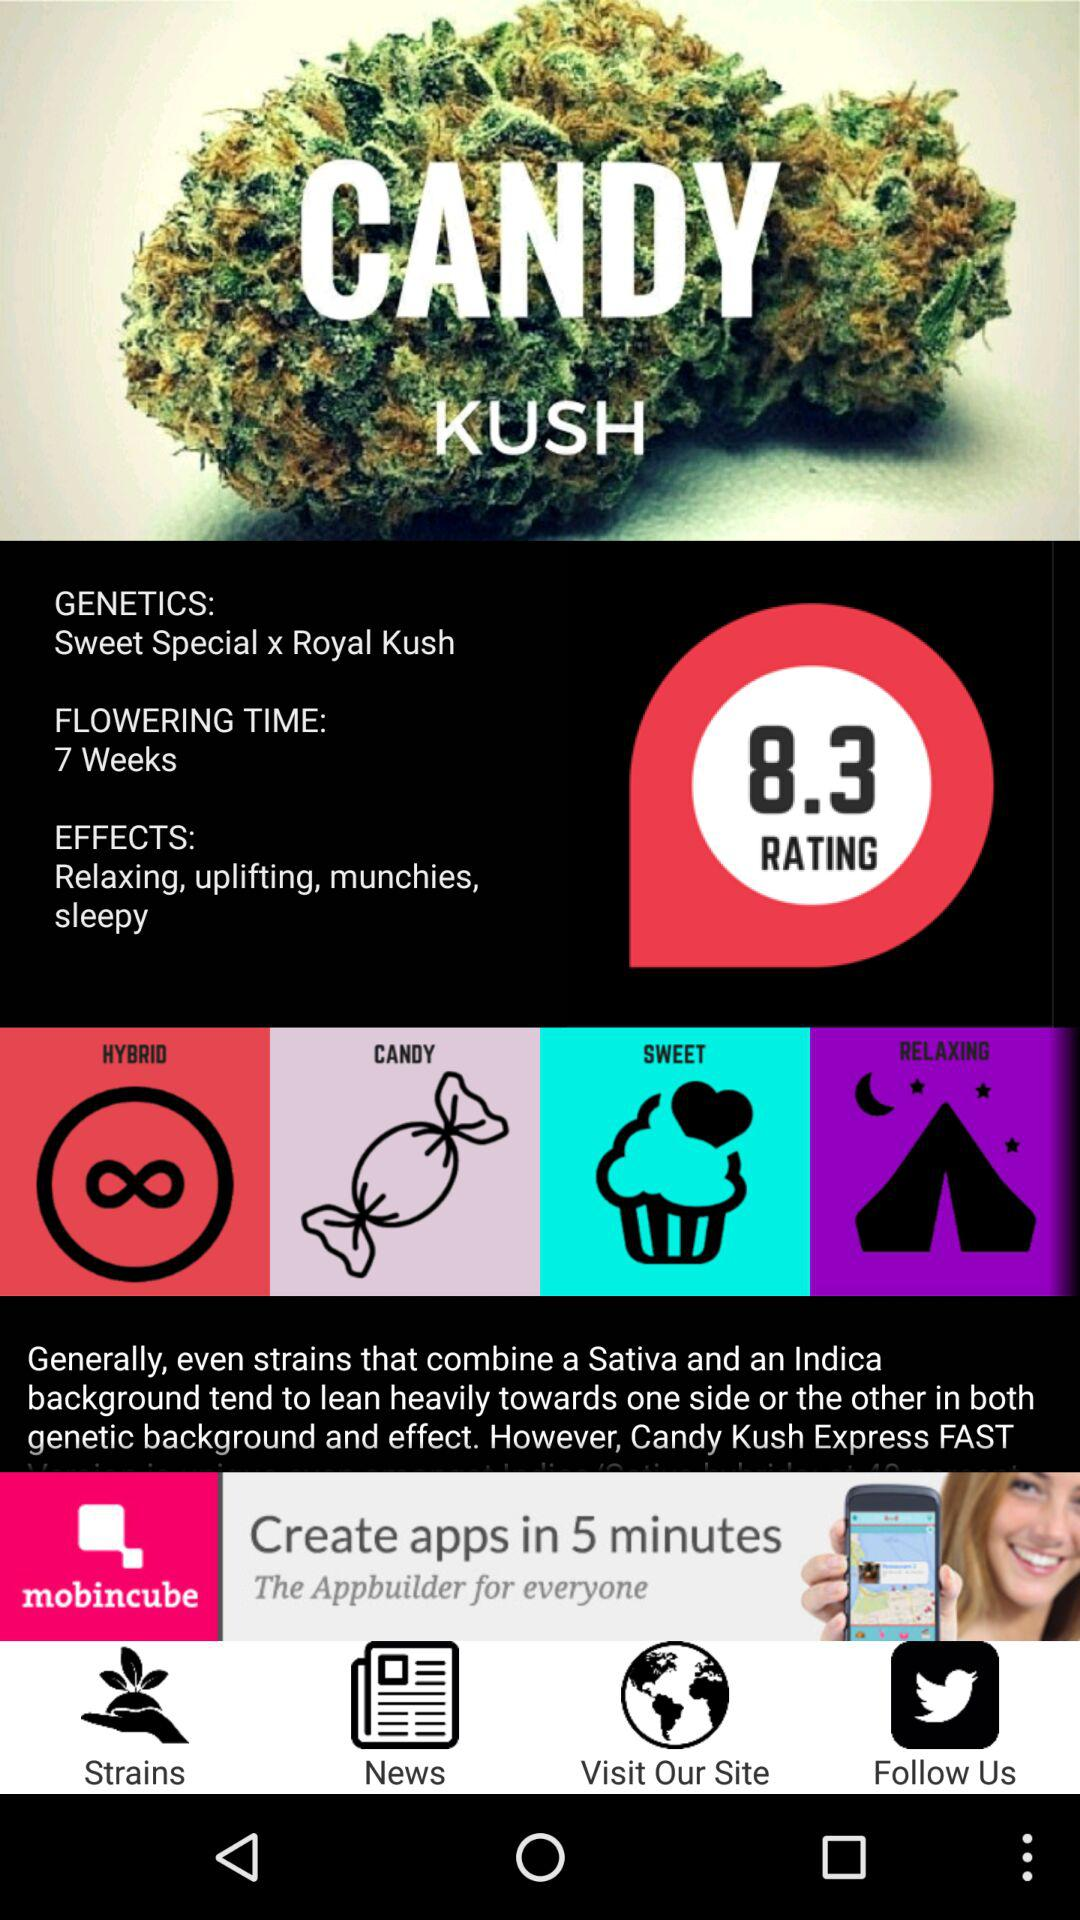What is the genetics of "CANDY KUSH"? The genetics of "CANDY KUSH" is "Sweet Special x Royal Kushi". 